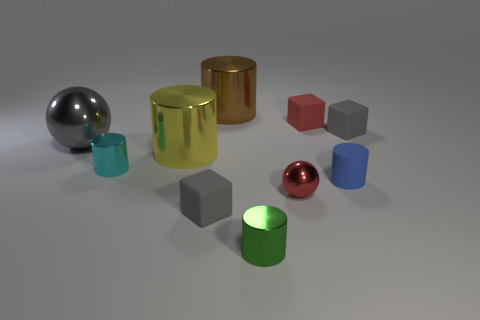What is the size of the gray matte object that is behind the blue object?
Your response must be concise. Small. What number of gray matte things are the same size as the gray sphere?
Keep it short and to the point. 0. What is the size of the thing that is the same color as the tiny shiny ball?
Ensure brevity in your answer.  Small. Is there a large metal cylinder that has the same color as the matte cylinder?
Provide a succinct answer. No. There is a rubber cylinder that is the same size as the red metallic object; what color is it?
Offer a very short reply. Blue. There is a big sphere; is its color the same as the metal ball that is right of the big brown thing?
Provide a short and direct response. No. What color is the matte cylinder?
Keep it short and to the point. Blue. What is the gray ball that is to the left of the cyan object made of?
Your response must be concise. Metal. What is the size of the blue matte object that is the same shape as the cyan metallic object?
Keep it short and to the point. Small. Is the number of red rubber objects that are in front of the tiny red rubber thing less than the number of cylinders?
Ensure brevity in your answer.  Yes. 